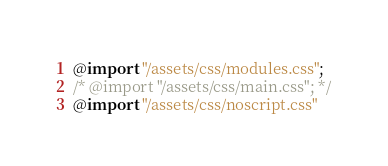Convert code to text. <code><loc_0><loc_0><loc_500><loc_500><_CSS_>@import "/assets/css/modules.css";
/* @import "/assets/css/main.css"; */
@import "/assets/css/noscript.css"

</code> 